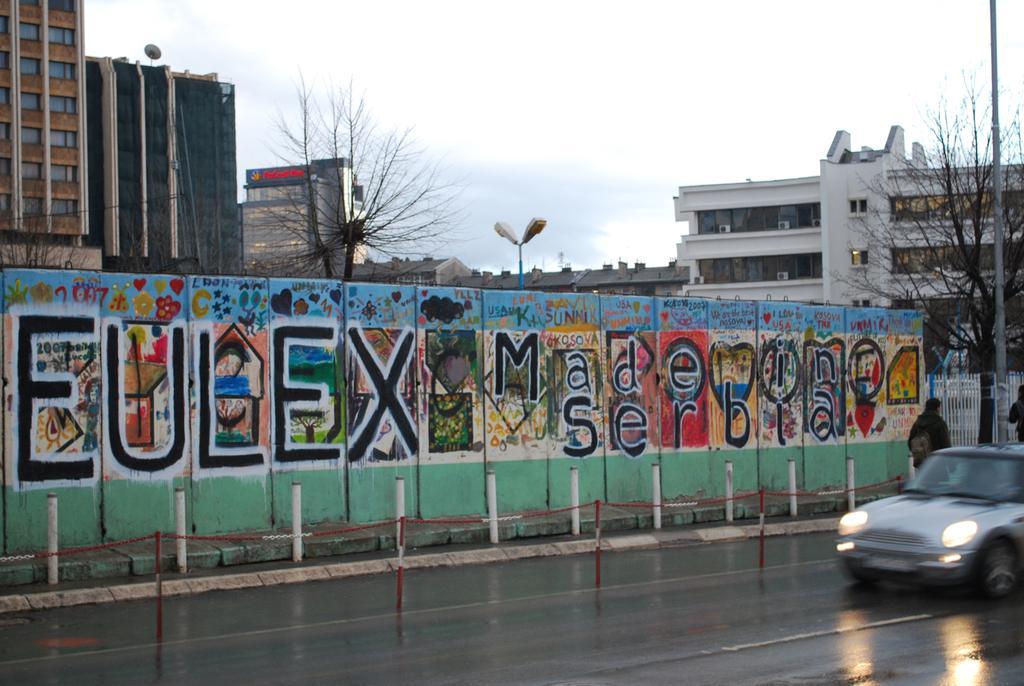Describe this image in one or two sentences. This picture is clicked on road. To the right corner there is car. There are people walking on the walkway. On the wall behind the walkway there is text and colorful images of flowers, butterflies, clouds, hearts and many other things. In the background there are buildings, street lights, poles, trees and sky. There is a dish antenna on a building. 